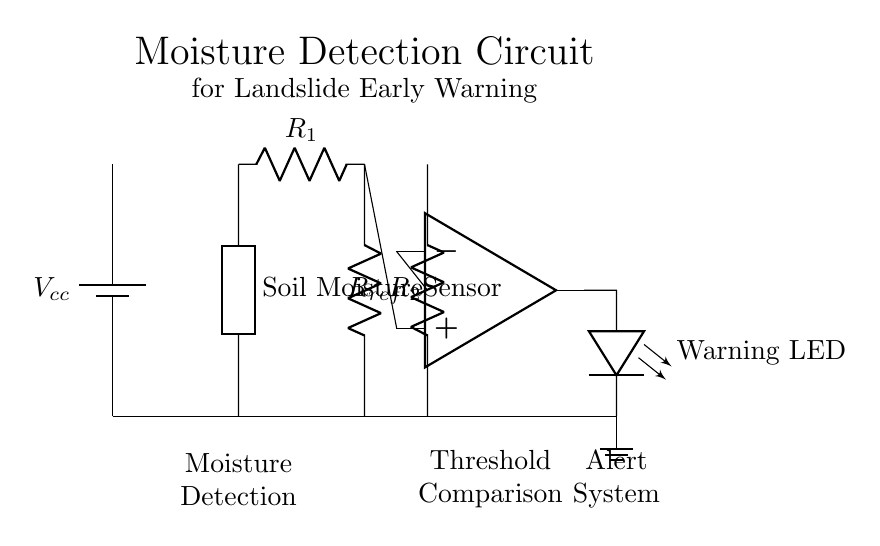What is the purpose of the soil moisture sensor? The soil moisture sensor is used to detect the moisture level in the soil, which is essential for determining potential landslide conditions.
Answer: Moisture detection What component is used to compare the moisture level? The comparator, specifically an operational amplifier, is used to compare the moisture sensor output against a reference level to trigger an alert.
Answer: Comparator What are the two resistors in the circuit? The two resistors, labeled R1 and R2, form a voltage divider that helps scale the signal from the moisture sensor for comparison in the op-amp.
Answer: Resistors What indicates a warning in the circuit? The warning LED lights up to provide a visual indication that the moisture level has crossed a certain threshold, suggesting a risk of landslides.
Answer: Warning LED What type of circuit is this? This is a moisture detection circuit designed for early warning systems in landslide-prone areas, which integrates sensing, comparison, and alerting functionalities.
Answer: Early warning system What is the reference resistor used for? The reference resistor, labeled Rref, sets a specific threshold level for the op-amp to determine when the warning should be triggered based on moisture levels.
Answer: Threshold setting What does the ground symbol indicate in this circuit? The ground symbol indicates the common reference point for the circuit, which is essential for the safe operation and proper functioning of the components.
Answer: Common reference 